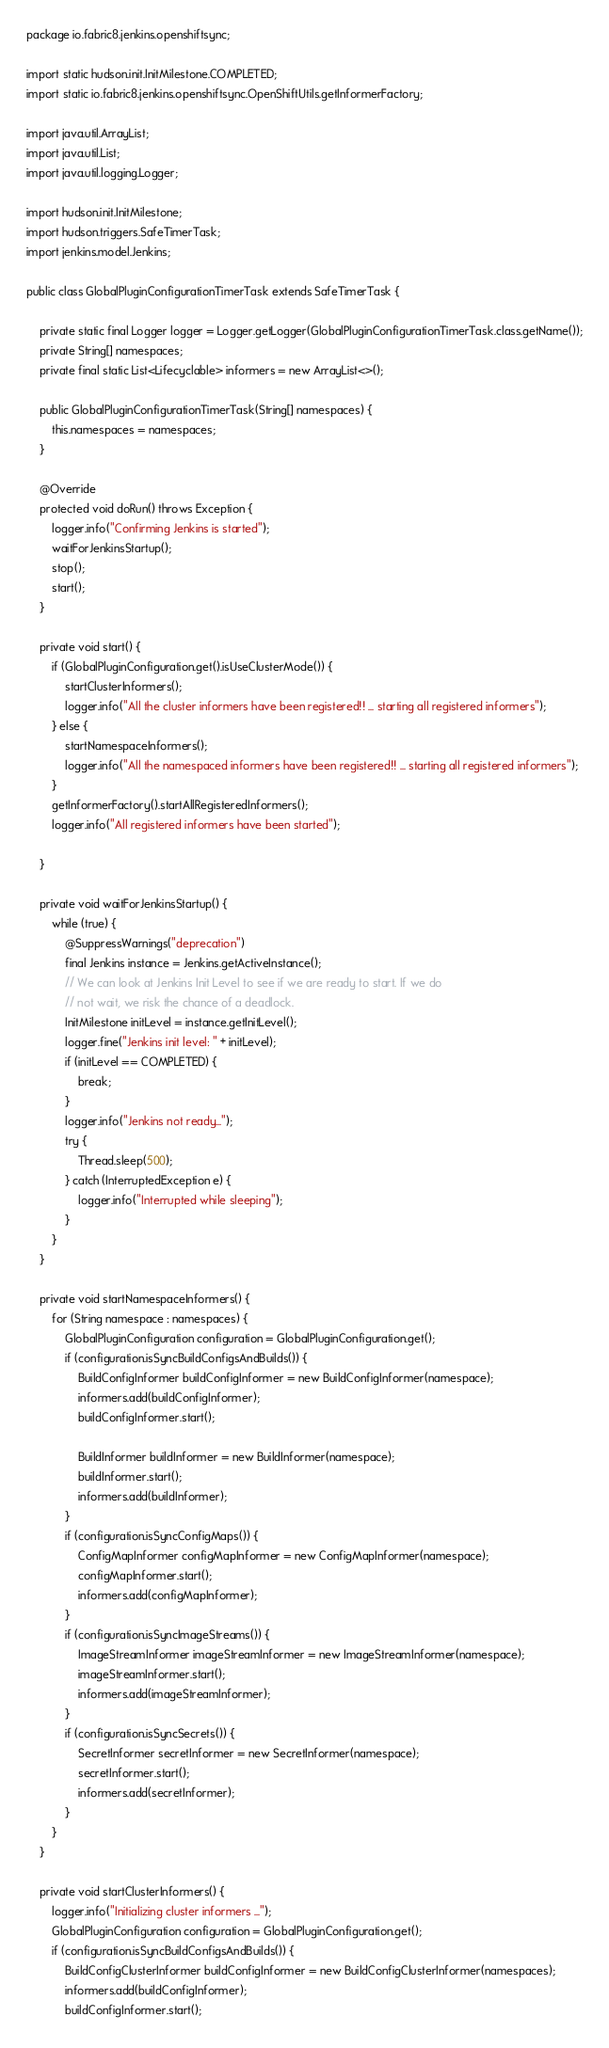<code> <loc_0><loc_0><loc_500><loc_500><_Java_>package io.fabric8.jenkins.openshiftsync;

import static hudson.init.InitMilestone.COMPLETED;
import static io.fabric8.jenkins.openshiftsync.OpenShiftUtils.getInformerFactory;

import java.util.ArrayList;
import java.util.List;
import java.util.logging.Logger;

import hudson.init.InitMilestone;
import hudson.triggers.SafeTimerTask;
import jenkins.model.Jenkins;

public class GlobalPluginConfigurationTimerTask extends SafeTimerTask {

    private static final Logger logger = Logger.getLogger(GlobalPluginConfigurationTimerTask.class.getName());
    private String[] namespaces;
    private final static List<Lifecyclable> informers = new ArrayList<>();

    public GlobalPluginConfigurationTimerTask(String[] namespaces) {
        this.namespaces = namespaces;
    }

    @Override
    protected void doRun() throws Exception {
        logger.info("Confirming Jenkins is started");
        waitForJenkinsStartup();
        stop();
        start();
    }

    private void start() {
        if (GlobalPluginConfiguration.get().isUseClusterMode()) {
            startClusterInformers();
            logger.info("All the cluster informers have been registered!! ... starting all registered informers");
        } else {
            startNamespaceInformers();
            logger.info("All the namespaced informers have been registered!! ... starting all registered informers");
        }
        getInformerFactory().startAllRegisteredInformers();
        logger.info("All registered informers have been started");

    }

    private void waitForJenkinsStartup() {
        while (true) {
            @SuppressWarnings("deprecation")
            final Jenkins instance = Jenkins.getActiveInstance();
            // We can look at Jenkins Init Level to see if we are ready to start. If we do
            // not wait, we risk the chance of a deadlock.
            InitMilestone initLevel = instance.getInitLevel();
            logger.fine("Jenkins init level: " + initLevel);
            if (initLevel == COMPLETED) {
                break;
            }
            logger.info("Jenkins not ready...");
            try {
                Thread.sleep(500);
            } catch (InterruptedException e) {
                logger.info("Interrupted while sleeping");
            }
        }
    }

    private void startNamespaceInformers() {
        for (String namespace : namespaces) {
            GlobalPluginConfiguration configuration = GlobalPluginConfiguration.get();
            if (configuration.isSyncBuildConfigsAndBuilds()) {
                BuildConfigInformer buildConfigInformer = new BuildConfigInformer(namespace);
                informers.add(buildConfigInformer);
                buildConfigInformer.start();

                BuildInformer buildInformer = new BuildInformer(namespace);
                buildInformer.start();
                informers.add(buildInformer);
            }
            if (configuration.isSyncConfigMaps()) {
                ConfigMapInformer configMapInformer = new ConfigMapInformer(namespace);
                configMapInformer.start();
                informers.add(configMapInformer);
            }
            if (configuration.isSyncImageStreams()) {
                ImageStreamInformer imageStreamInformer = new ImageStreamInformer(namespace);
                imageStreamInformer.start();
                informers.add(imageStreamInformer);
            }
            if (configuration.isSyncSecrets()) {
                SecretInformer secretInformer = new SecretInformer(namespace);
                secretInformer.start();
                informers.add(secretInformer);
            }
        }
    }

    private void startClusterInformers() {
        logger.info("Initializing cluster informers ...");
        GlobalPluginConfiguration configuration = GlobalPluginConfiguration.get();
        if (configuration.isSyncBuildConfigsAndBuilds()) {
            BuildConfigClusterInformer buildConfigInformer = new BuildConfigClusterInformer(namespaces);
            informers.add(buildConfigInformer);
            buildConfigInformer.start();
</code> 